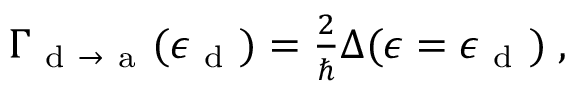<formula> <loc_0><loc_0><loc_500><loc_500>\begin{array} { r } { \Gamma _ { d \to a } ( \epsilon _ { d } ) = \frac { 2 } { } \Delta ( \epsilon = \epsilon _ { d } ) \, , } \end{array}</formula> 